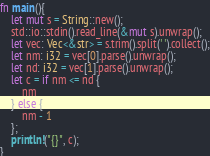<code> <loc_0><loc_0><loc_500><loc_500><_Rust_>fn main(){
	let mut s = String::new();
	std::io::stdin().read_line(&mut s).unwrap();
	let vec: Vec<&str> = s.trim().split(' ').collect();
	let nm: i32 = vec[0].parse().unwrap();
	let nd: i32 = vec[1].parse().unwrap();
	let c = if nm <= nd {
		nm
	} else {
		nm - 1
	};
	println!("{}", c);
}

</code> 